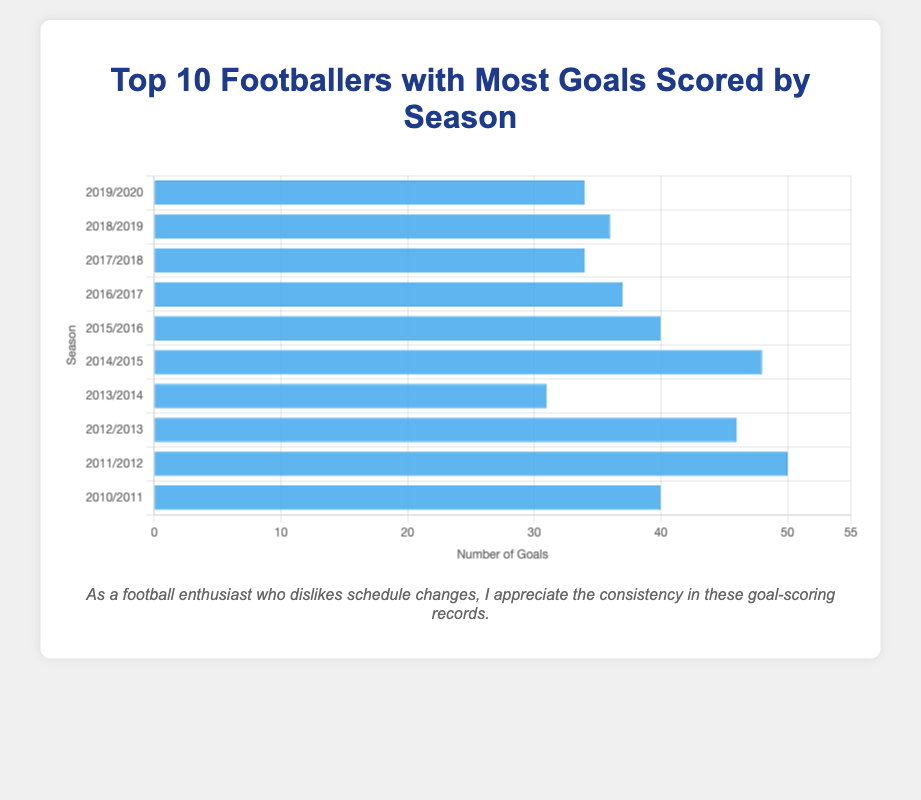Which footballer scored the most goals in a single season from 2010 to 2020? By glancing at the height of the bars, the tallest bar represents the highest number of goals scored in a single season. The tallest bar belongs to the 2011/2012 season and corresponds to Lionel Messi with 50 goals.
Answer: Lionel Messi Which season did Cristiano Ronaldo have the highest number of goals based on the chart? Cristiano Ronaldo has multiple bars, and the tallest one corresponds to the 2014/2015 season where he scored 48 goals.
Answer: 2014/2015 What's the difference in goals scored between Luis Suárez in 2015/2016 and Robert Lewandowski in 2019/2020? Luis Suárez scored 40 goals in the 2015/2016 season while Robert Lewandowski scored 34 goals in the 2019/2020 season. The difference is 40 - 34, which equals 6 goals.
Answer: 6 goals Which player appears most frequently in this chart for scoring the most goals by season? By counting the occurrences of each player's name, Lionel Messi appears most frequently with bars for the seasons 2018/2019, 2017/2018, 2016/2017, 2012/2013, and 2011/2012.
Answer: Lionel Messi What is the combined total of goals scored by the top players in the 2013/2014 and 2010/2011 seasons? The top player in the 2013/2014 season is Cristiano Ronaldo with 31 goals, and in the 2010/2011 season, it is Cristiano Ronaldo again with 40 goals. Combined, the total is 31 + 40, which equals 71 goals.
Answer: 71 goals Who scored more goals in the 2012/2013 season than the number of goals scored by the top player in the 2013/2014 season, and how many more? Lionel Messi scored 46 goals in the 2012/2013 season, whereas Cristiano Ronaldo scored 31 goals in the 2013/2014 season. The difference between these two is 46 - 31, which equals 15 goals.
Answer: Lionel Messi, 15 goals What is the average number of goals scored by the top players across all the seasons shown in the chart? The total number of goals scored across all seasons is 34 + 36 + 34 + 37 + 40 + 48 + 31 + 46 + 50 + 40. Summing these gives 396. The number of seasons is 10, so the average is 396 / 10, which equals 39.6 goals.
Answer: 39.6 goals 